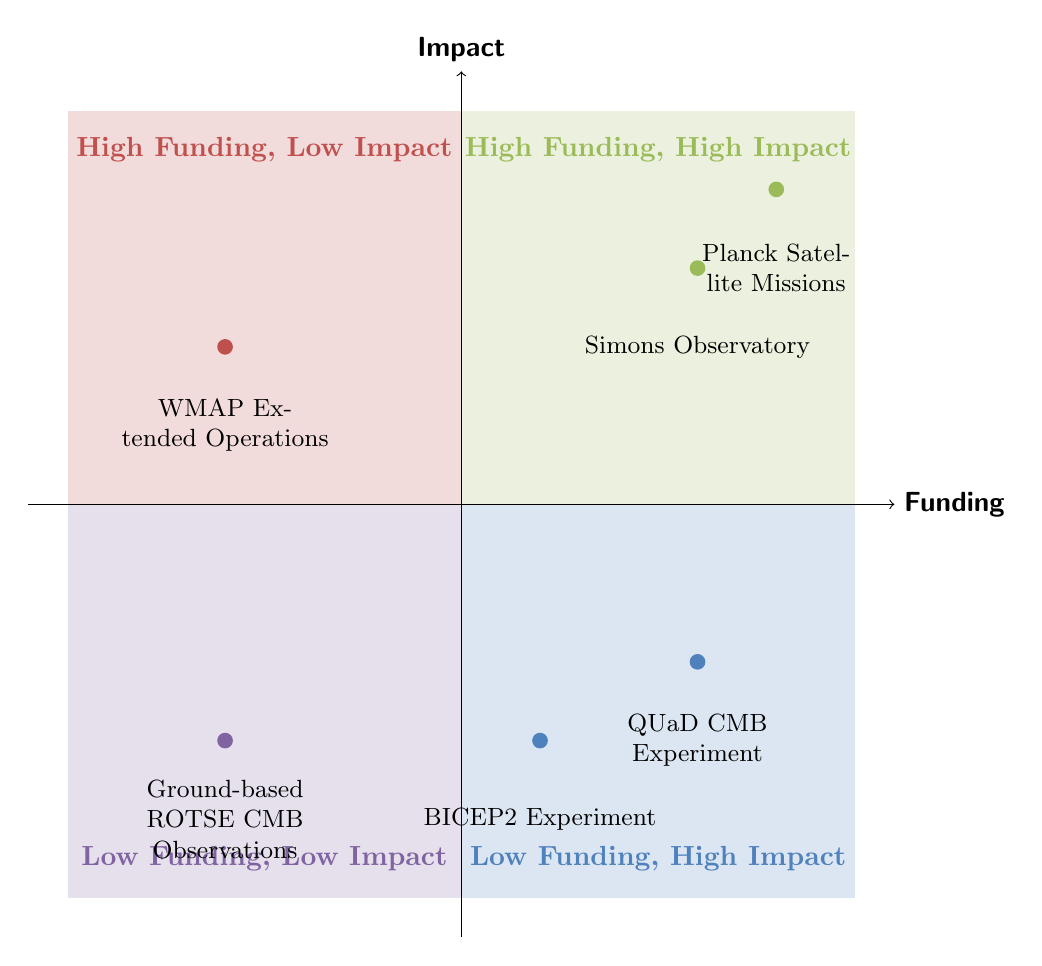What's the total funding for projects in the "High Funding, High Impact" quadrant? In the "High Funding, High Impact" quadrant, there are two projects: Planck Satellite Missions with 750 million Euros and Simons Observatory with 40 million dollars. Adding these amounts gives us 750 million + 40 million = 790 million total funding.
Answer: 790 million How many experiments are listed in the "Low Funding, High Impact" quadrant? In the "Low Funding, High Impact" quadrant, there are two experiments mentioned: BICEP2 Experiment and QUaD CMB Experiment. Therefore, the count of projects is 2.
Answer: 2 What is the impact of the Simons Observatory? The Simons Observatory's impact is stated as "Next-generation measurements of CMB polarization." This is the specific phrasing in the diagram regarding its impact.
Answer: Next-generation measurements of CMB polarization Which project has the lowest funding and what is the amount? The project with the lowest funding listed is the Ground-based ROTSE CMB Observations, which has a funding amount of 0.5 million dollars. By assessing the funding values across quadrants, this is confirmed as the least.
Answer: 0.5 million What can be inferred about the relationship between funding and impact for the WMAP Extended Operations? The WMAP Extended Operations is categorized in the "High Funding, Low Impact" quadrant, which indicates that despite receiving a significant funding of 110 million dollars, its impact is limited. This infers that high funding does not always guarantee high impact.
Answer: High funding, low impact Which quadrant contains the Planck Satellite Missions? The Planck Satellite Missions are located in the "High Funding, High Impact" quadrant. Referring directly to the quadrant categorization, this projects into the quadrant's description.
Answer: High Funding, High Impact What is the total funding for projects in the "Low Funding, Low Impact" quadrant? In the "Low Funding, Low Impact" quadrant, there is only one project: Ground-based ROTSE CMB Observations with 0.5 million dollars. Thus, the total funding for this quadrant is simply the amount stated for this single project.
Answer: 0.5 million What does the BICEP2 Experiment claim to have detected? The BICEP2 Experiment is noted for its preliminary claim of detection of gravitational waves in CMB polarization, as explicitly mentioned in its impact statement within the diagram.
Answer: Detected gravitational waves in CMB polarization Which quadrant has only one project listed, and what is its name? The "High Funding, Low Impact" quadrant has only one project listed, which is the WMAP Extended Operations. This is determined by counting the number of listed projects in each quadrant.
Answer: WMAP Extended Operations 